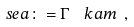<formula> <loc_0><loc_0><loc_500><loc_500>\ s e a \colon = \Gamma \ \ k a m \ ,</formula> 